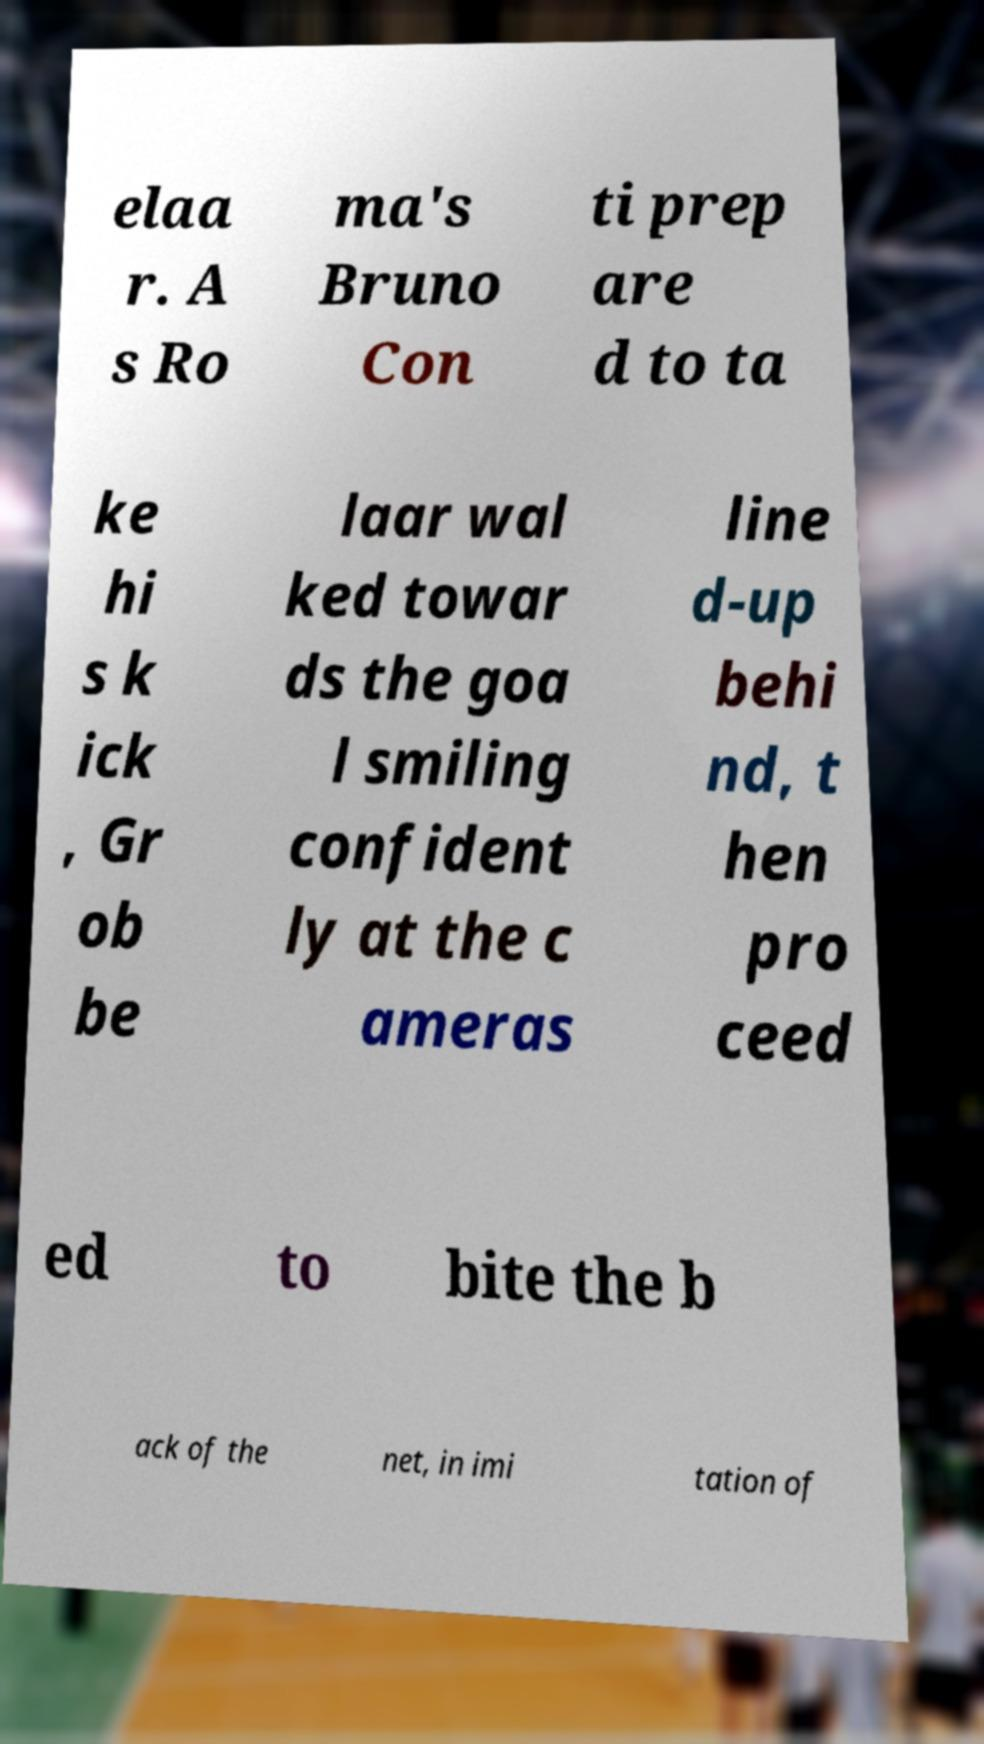Please identify and transcribe the text found in this image. elaa r. A s Ro ma's Bruno Con ti prep are d to ta ke hi s k ick , Gr ob be laar wal ked towar ds the goa l smiling confident ly at the c ameras line d-up behi nd, t hen pro ceed ed to bite the b ack of the net, in imi tation of 